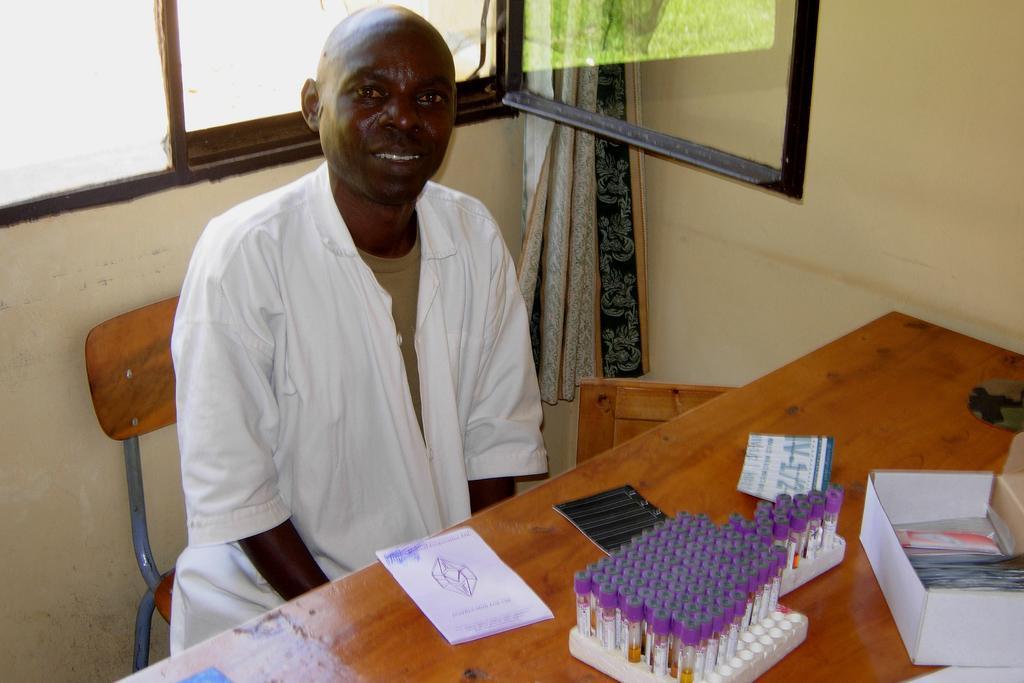How would you summarize this image in a sentence or two? In this image we can see a man sitting on a chair beside a table containing some papers, a book, tubes in a stand and a cardboard box which are placed on it. We can also see a window, wall and a curtain. 